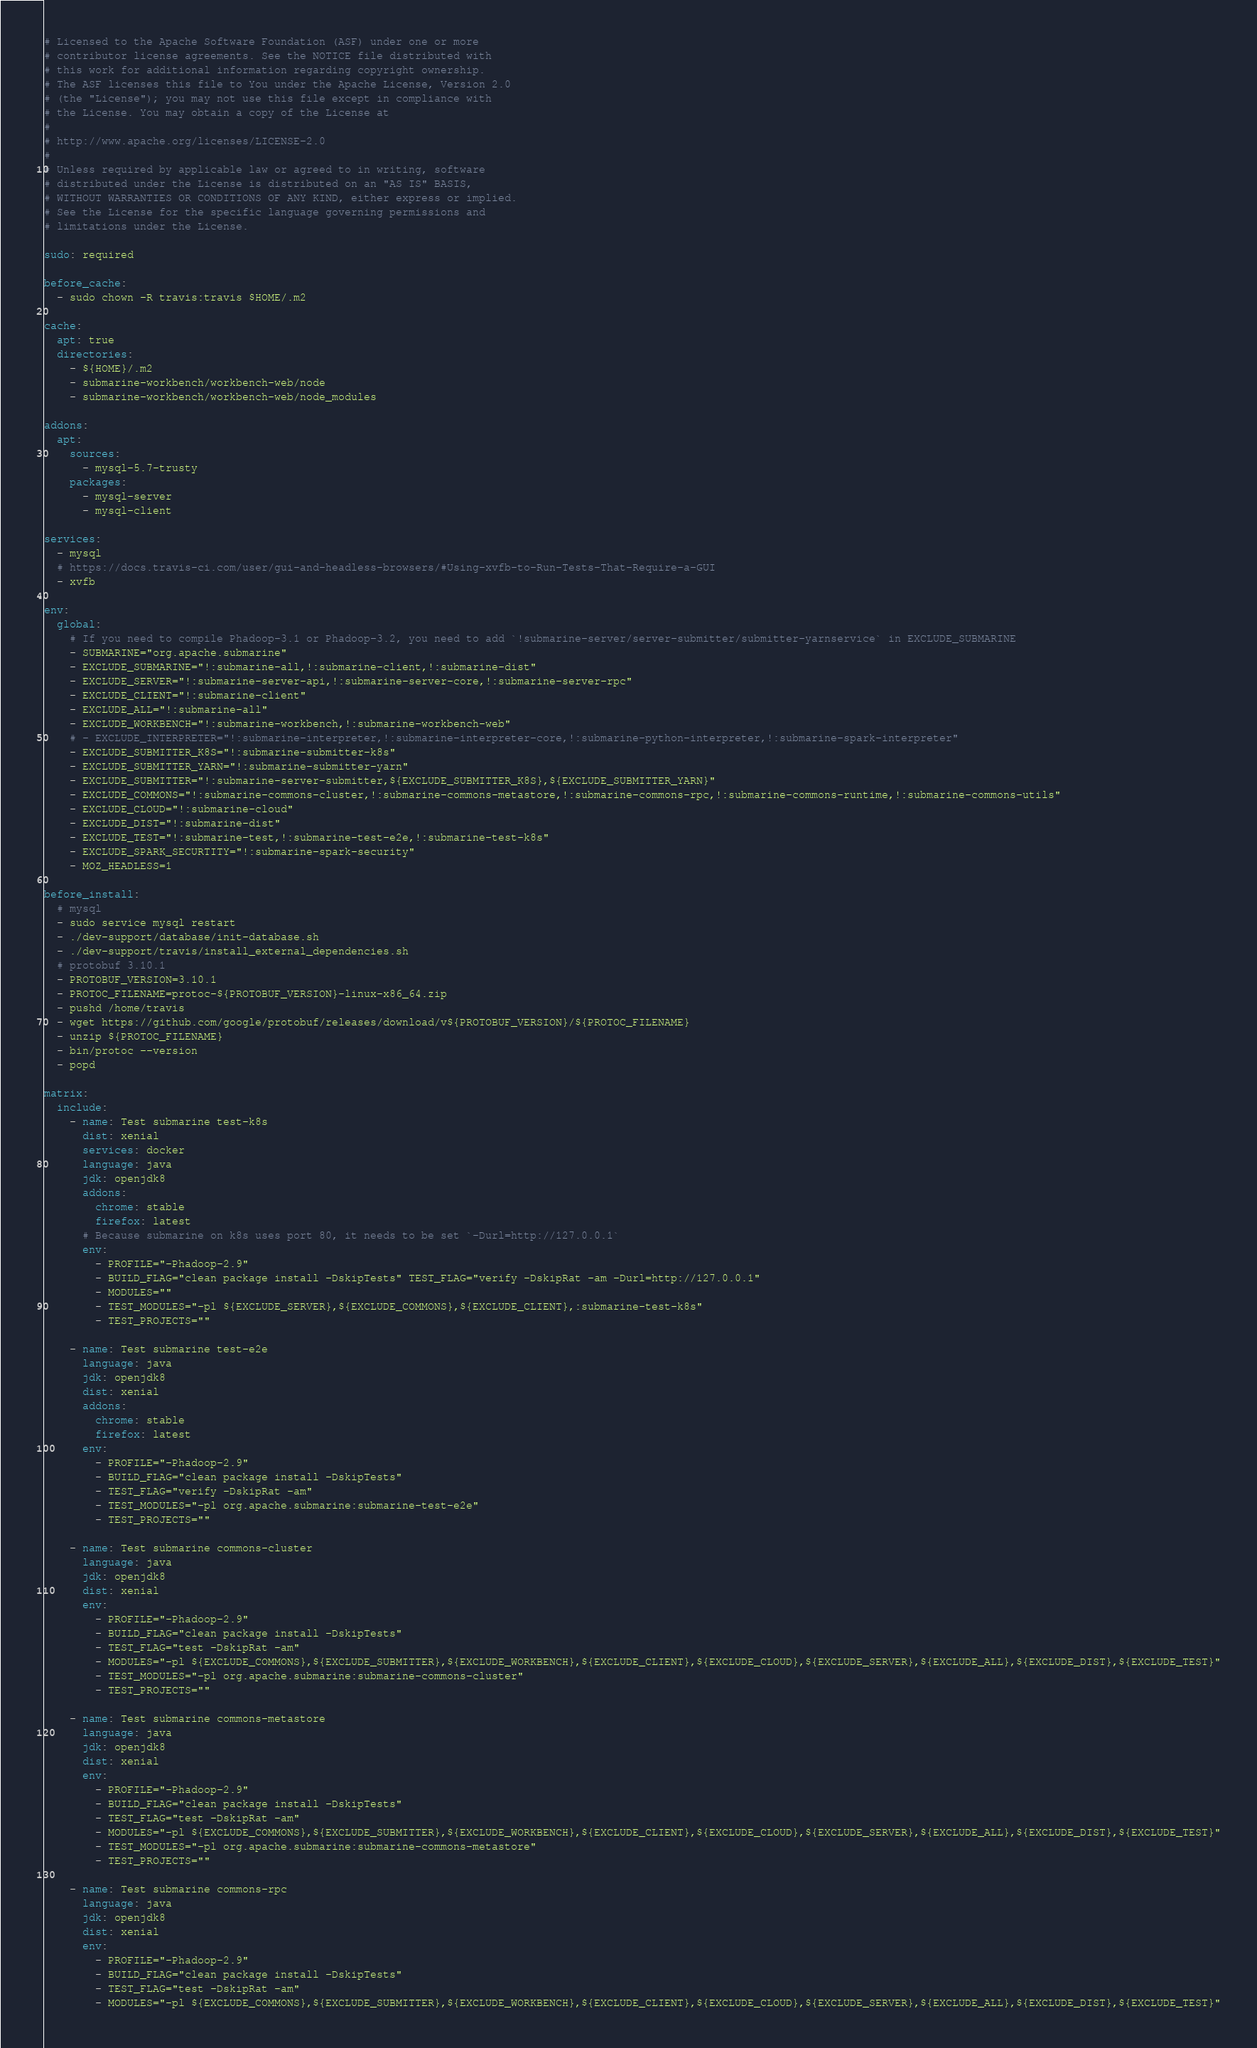<code> <loc_0><loc_0><loc_500><loc_500><_YAML_># Licensed to the Apache Software Foundation (ASF) under one or more
# contributor license agreements. See the NOTICE file distributed with
# this work for additional information regarding copyright ownership.
# The ASF licenses this file to You under the Apache License, Version 2.0
# (the "License"); you may not use this file except in compliance with
# the License. You may obtain a copy of the License at
#
# http://www.apache.org/licenses/LICENSE-2.0
#
# Unless required by applicable law or agreed to in writing, software
# distributed under the License is distributed on an "AS IS" BASIS,
# WITHOUT WARRANTIES OR CONDITIONS OF ANY KIND, either express or implied.
# See the License for the specific language governing permissions and
# limitations under the License.

sudo: required

before_cache:
  - sudo chown -R travis:travis $HOME/.m2

cache:
  apt: true
  directories:
    - ${HOME}/.m2
    - submarine-workbench/workbench-web/node
    - submarine-workbench/workbench-web/node_modules

addons:
  apt:
    sources:
      - mysql-5.7-trusty
    packages:
      - mysql-server
      - mysql-client

services:
  - mysql
  # https://docs.travis-ci.com/user/gui-and-headless-browsers/#Using-xvfb-to-Run-Tests-That-Require-a-GUI
  - xvfb

env:
  global:
    # If you need to compile Phadoop-3.1 or Phadoop-3.2, you need to add `!submarine-server/server-submitter/submitter-yarnservice` in EXCLUDE_SUBMARINE
    - SUBMARINE="org.apache.submarine"
    - EXCLUDE_SUBMARINE="!:submarine-all,!:submarine-client,!:submarine-dist"
    - EXCLUDE_SERVER="!:submarine-server-api,!:submarine-server-core,!:submarine-server-rpc"
    - EXCLUDE_CLIENT="!:submarine-client"
    - EXCLUDE_ALL="!:submarine-all"
    - EXCLUDE_WORKBENCH="!:submarine-workbench,!:submarine-workbench-web"
    # - EXCLUDE_INTERPRETER="!:submarine-interpreter,!:submarine-interpreter-core,!:submarine-python-interpreter,!:submarine-spark-interpreter"
    - EXCLUDE_SUBMITTER_K8S="!:submarine-submitter-k8s"
    - EXCLUDE_SUBMITTER_YARN="!:submarine-submitter-yarn"
    - EXCLUDE_SUBMITTER="!:submarine-server-submitter,${EXCLUDE_SUBMITTER_K8S},${EXCLUDE_SUBMITTER_YARN}"
    - EXCLUDE_COMMONS="!:submarine-commons-cluster,!:submarine-commons-metastore,!:submarine-commons-rpc,!:submarine-commons-runtime,!:submarine-commons-utils"
    - EXCLUDE_CLOUD="!:submarine-cloud"
    - EXCLUDE_DIST="!:submarine-dist"
    - EXCLUDE_TEST="!:submarine-test,!:submarine-test-e2e,!:submarine-test-k8s"
    - EXCLUDE_SPARK_SECURTITY="!:submarine-spark-security"
    - MOZ_HEADLESS=1

before_install:
  # mysql
  - sudo service mysql restart
  - ./dev-support/database/init-database.sh
  - ./dev-support/travis/install_external_dependencies.sh
  # protobuf 3.10.1
  - PROTOBUF_VERSION=3.10.1
  - PROTOC_FILENAME=protoc-${PROTOBUF_VERSION}-linux-x86_64.zip
  - pushd /home/travis
  - wget https://github.com/google/protobuf/releases/download/v${PROTOBUF_VERSION}/${PROTOC_FILENAME}
  - unzip ${PROTOC_FILENAME}
  - bin/protoc --version
  - popd

matrix:
  include:
    - name: Test submarine test-k8s
      dist: xenial
      services: docker
      language: java
      jdk: openjdk8
      addons:
        chrome: stable
        firefox: latest
      # Because submarine on k8s uses port 80, it needs to be set `-Durl=http://127.0.0.1`
      env:
        - PROFILE="-Phadoop-2.9"
        - BUILD_FLAG="clean package install -DskipTests" TEST_FLAG="verify -DskipRat -am -Durl=http://127.0.0.1"
        - MODULES=""
        - TEST_MODULES="-pl ${EXCLUDE_SERVER},${EXCLUDE_COMMONS},${EXCLUDE_CLIENT},:submarine-test-k8s"
        - TEST_PROJECTS=""

    - name: Test submarine test-e2e
      language: java
      jdk: openjdk8
      dist: xenial
      addons:
        chrome: stable
        firefox: latest
      env:
        - PROFILE="-Phadoop-2.9"
        - BUILD_FLAG="clean package install -DskipTests"
        - TEST_FLAG="verify -DskipRat -am"
        - TEST_MODULES="-pl org.apache.submarine:submarine-test-e2e"
        - TEST_PROJECTS=""

    - name: Test submarine commons-cluster
      language: java
      jdk: openjdk8
      dist: xenial
      env:
        - PROFILE="-Phadoop-2.9"
        - BUILD_FLAG="clean package install -DskipTests"
        - TEST_FLAG="test -DskipRat -am"
        - MODULES="-pl ${EXCLUDE_COMMONS},${EXCLUDE_SUBMITTER},${EXCLUDE_WORKBENCH},${EXCLUDE_CLIENT},${EXCLUDE_CLOUD},${EXCLUDE_SERVER},${EXCLUDE_ALL},${EXCLUDE_DIST},${EXCLUDE_TEST}"
        - TEST_MODULES="-pl org.apache.submarine:submarine-commons-cluster"
        - TEST_PROJECTS=""

    - name: Test submarine commons-metastore
      language: java
      jdk: openjdk8
      dist: xenial
      env:
        - PROFILE="-Phadoop-2.9"
        - BUILD_FLAG="clean package install -DskipTests"
        - TEST_FLAG="test -DskipRat -am"
        - MODULES="-pl ${EXCLUDE_COMMONS},${EXCLUDE_SUBMITTER},${EXCLUDE_WORKBENCH},${EXCLUDE_CLIENT},${EXCLUDE_CLOUD},${EXCLUDE_SERVER},${EXCLUDE_ALL},${EXCLUDE_DIST},${EXCLUDE_TEST}"
        - TEST_MODULES="-pl org.apache.submarine:submarine-commons-metastore"
        - TEST_PROJECTS=""

    - name: Test submarine commons-rpc
      language: java
      jdk: openjdk8
      dist: xenial
      env:
        - PROFILE="-Phadoop-2.9"
        - BUILD_FLAG="clean package install -DskipTests"
        - TEST_FLAG="test -DskipRat -am"
        - MODULES="-pl ${EXCLUDE_COMMONS},${EXCLUDE_SUBMITTER},${EXCLUDE_WORKBENCH},${EXCLUDE_CLIENT},${EXCLUDE_CLOUD},${EXCLUDE_SERVER},${EXCLUDE_ALL},${EXCLUDE_DIST},${EXCLUDE_TEST}"</code> 